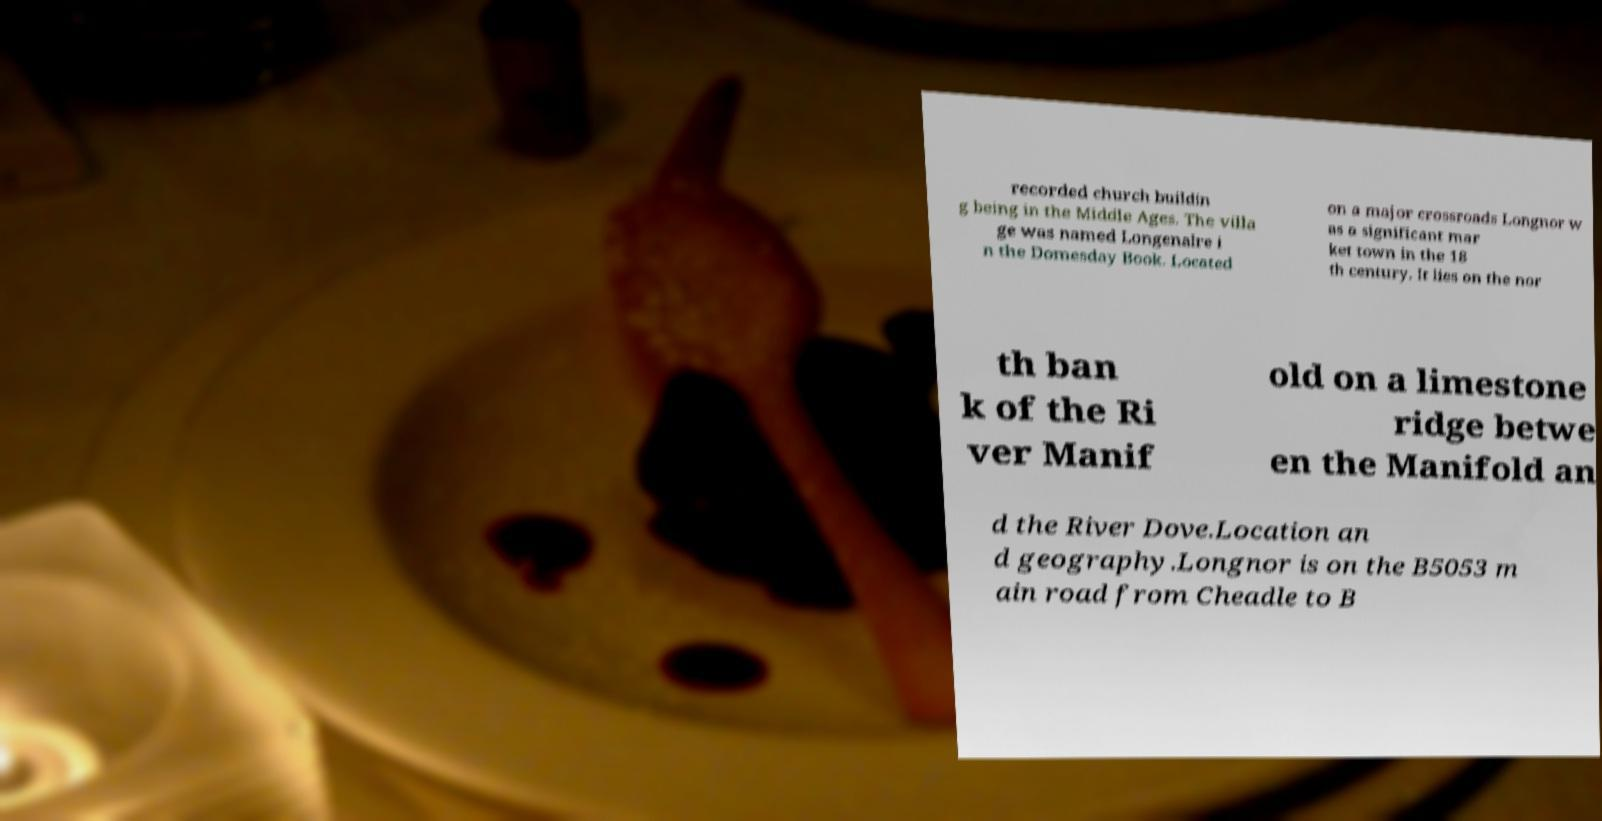What messages or text are displayed in this image? I need them in a readable, typed format. recorded church buildin g being in the Middle Ages. The villa ge was named Longenalre i n the Domesday Book. Located on a major crossroads Longnor w as a significant mar ket town in the 18 th century. It lies on the nor th ban k of the Ri ver Manif old on a limestone ridge betwe en the Manifold an d the River Dove.Location an d geography.Longnor is on the B5053 m ain road from Cheadle to B 